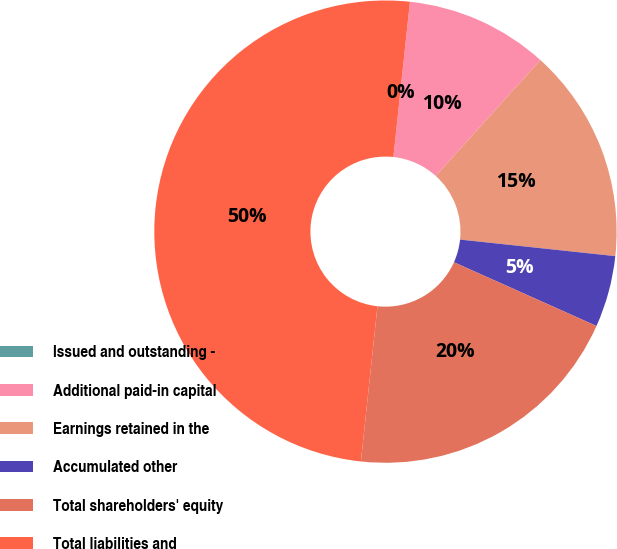Convert chart. <chart><loc_0><loc_0><loc_500><loc_500><pie_chart><fcel>Issued and outstanding -<fcel>Additional paid-in capital<fcel>Earnings retained in the<fcel>Accumulated other<fcel>Total shareholders' equity<fcel>Total liabilities and<nl><fcel>0.0%<fcel>10.0%<fcel>15.0%<fcel>5.0%<fcel>20.0%<fcel>49.99%<nl></chart> 